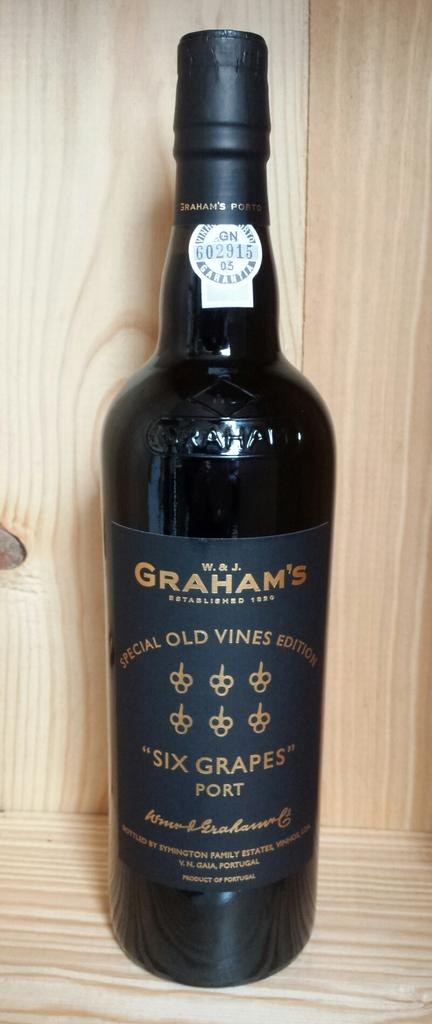<image>
Summarize the visual content of the image. A bottle of six grapes port sits on a wooden shelf. 